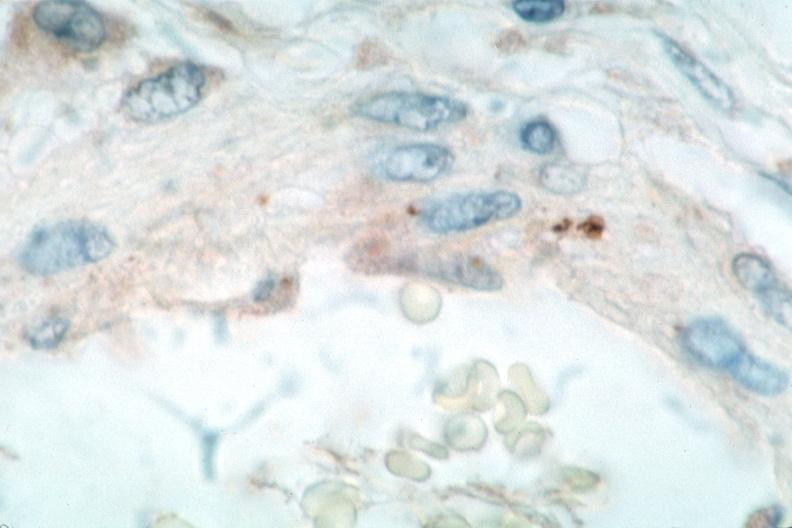what is present?
Answer the question using a single word or phrase. Vasculature 